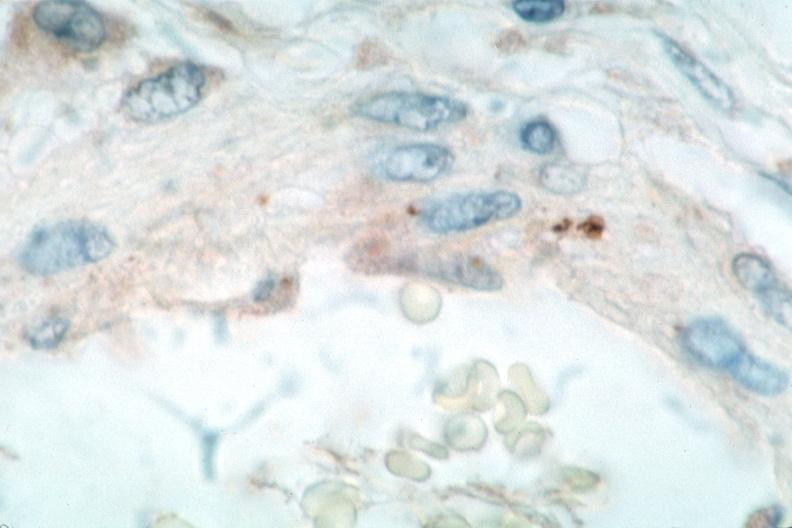what is present?
Answer the question using a single word or phrase. Vasculature 